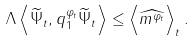<formula> <loc_0><loc_0><loc_500><loc_500>\Lambda \left \langle \widetilde { \Psi } _ { t } , q _ { 1 } ^ { \varphi _ { t } } \widetilde { \Psi } _ { t } \right \rangle \leq \left \langle \widehat { m ^ { \varphi _ { t } } } \right \rangle _ { t } .</formula> 